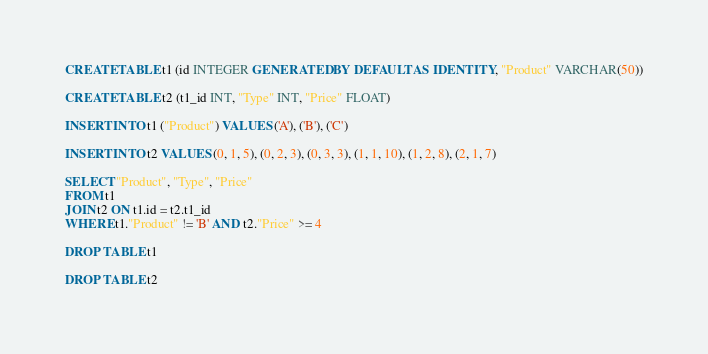Convert code to text. <code><loc_0><loc_0><loc_500><loc_500><_SQL_>CREATE TABLE t1 (id INTEGER GENERATED BY DEFAULT AS IDENTITY, "Product" VARCHAR(50))

CREATE TABLE t2 (t1_id INT, "Type" INT, "Price" FLOAT) 

INSERT INTO t1 ("Product") VALUES ('A'), ('B'), ('C')

INSERT INTO t2 VALUES (0, 1, 5), (0, 2, 3), (0, 3, 3), (1, 1, 10), (1, 2, 8), (2, 1, 7)

SELECT "Product", "Type", "Price"
FROM t1
JOIN t2 ON t1.id = t2.t1_id
WHERE t1."Product" != 'B' AND t2."Price" >= 4

DROP TABLE t1

DROP TABLE t2</code> 